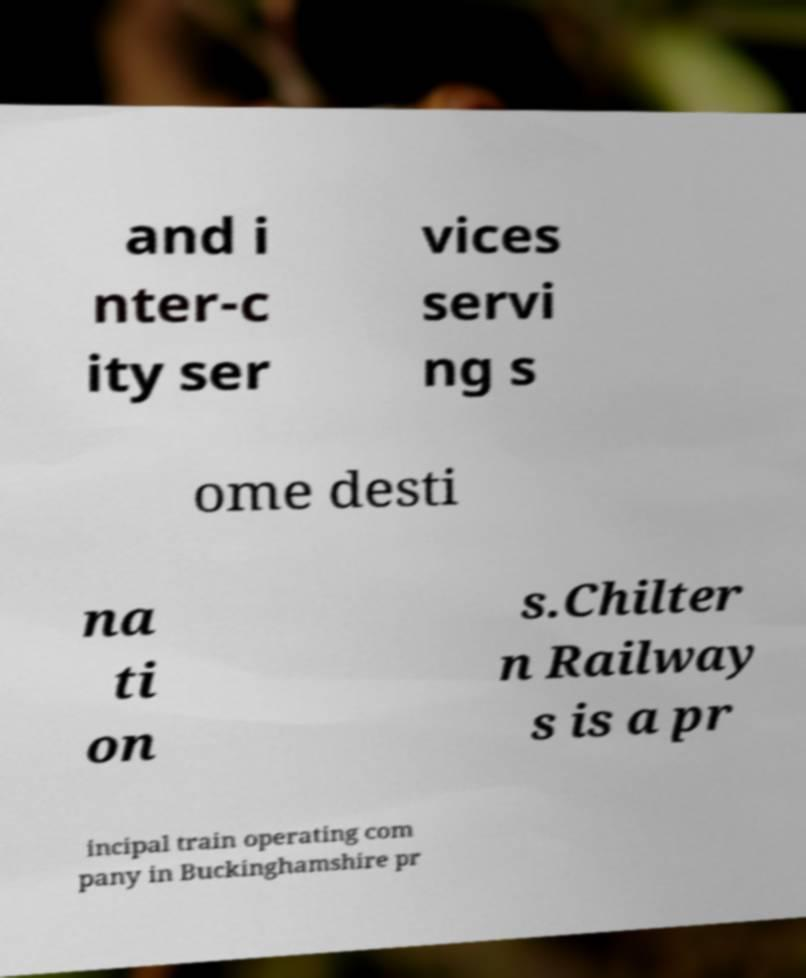Could you assist in decoding the text presented in this image and type it out clearly? and i nter-c ity ser vices servi ng s ome desti na ti on s.Chilter n Railway s is a pr incipal train operating com pany in Buckinghamshire pr 